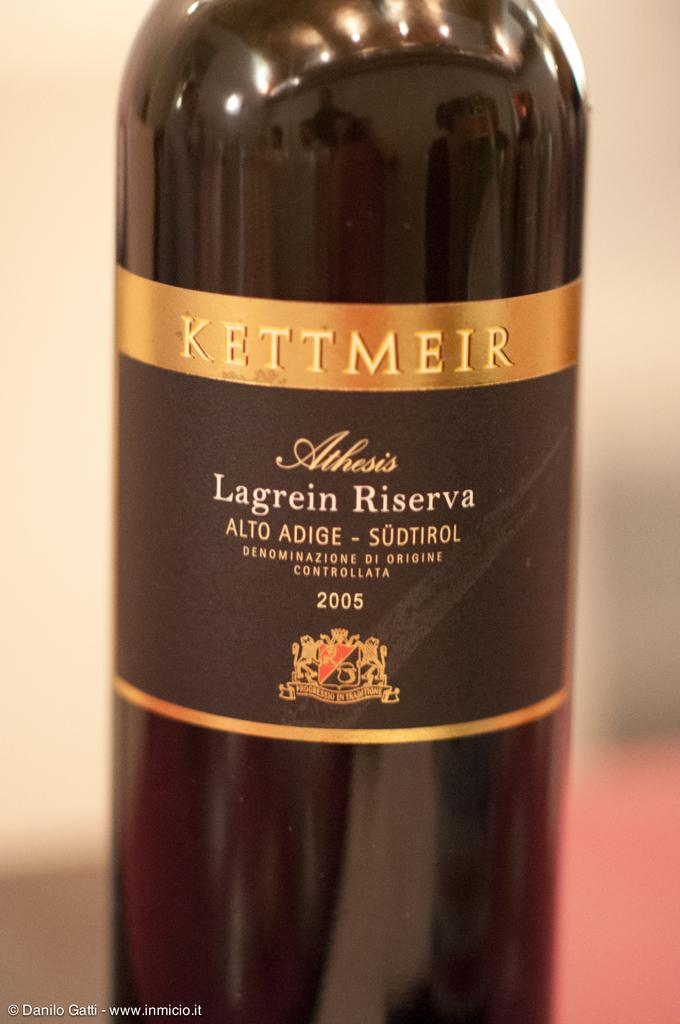<image>
Share a concise interpretation of the image provided. A bottle of 2005 Kettmeir wine is shown up close against a blurred background. 